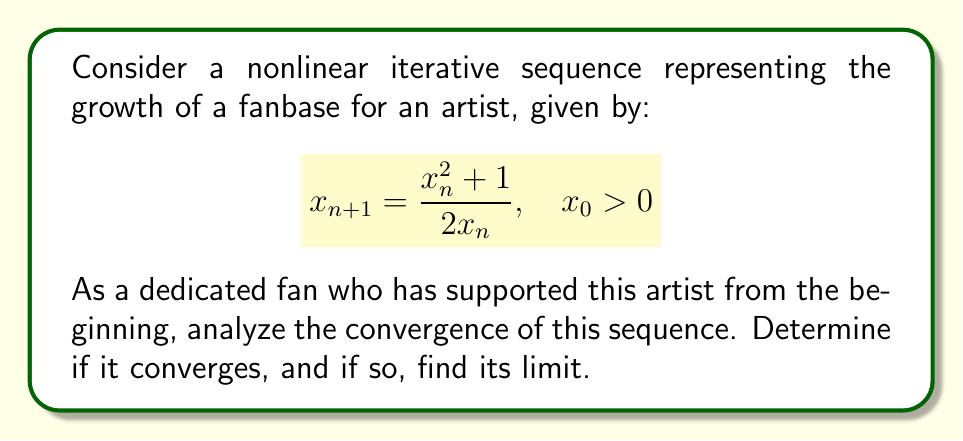Give your solution to this math problem. Let's approach this step-by-step:

1) First, we need to find the fixed points of the iteration. A fixed point $x^*$ satisfies:

   $$x^* = \frac{(x^*)^2 + 1}{2x^*}$$

2) Solving this equation:
   $2(x^*)^2 = (x^*)^2 + 1$
   $(x^*)^2 = 1$
   $x^* = \pm 1$

   Since $x_0 > 0$, we only consider the positive fixed point, $x^* = 1$.

3) To analyze convergence, we can use the derivative of the iteration function:

   $$f(x) = \frac{x^2 + 1}{2x}$$
   $$f'(x) = \frac{2x \cdot 2x - (x^2 + 1) \cdot 2}{4x^2} = \frac{x^2 - 1}{2x^2}$$

4) At the fixed point $x^* = 1$:

   $$|f'(1)| = \left|\frac{1^2 - 1}{2(1^2)}\right| = 0 < 1$$

5) Since $|f'(1)| < 1$, by the Fixed Point Theorem, the sequence converges to 1 for initial values close to 1.

6) To prove global convergence for all $x_0 > 0$, we can show that the sequence is monotonic and bounded:

   $$x_{n+1} - 1 = \frac{x_n^2 + 1}{2x_n} - 1 = \frac{x_n^2 + 1 - 2x_n}{2x_n} = \frac{(x_n - 1)^2}{2x_n} \geq 0$$

   This shows that $x_{n+1} \geq 1$ for all $n$ if $x_0 > 0$.

   Also, $x_{n+1} - x_n = \frac{x_n^2 + 1}{2x_n} - x_n = \frac{1 - x_n^2}{2x_n} \leq 0$ if $x_n \geq 1$.

7) Therefore, the sequence is decreasing and bounded below by 1, so it converges to 1 for all $x_0 > 0$.
Answer: The sequence converges to 1 for all $x_0 > 0$. 